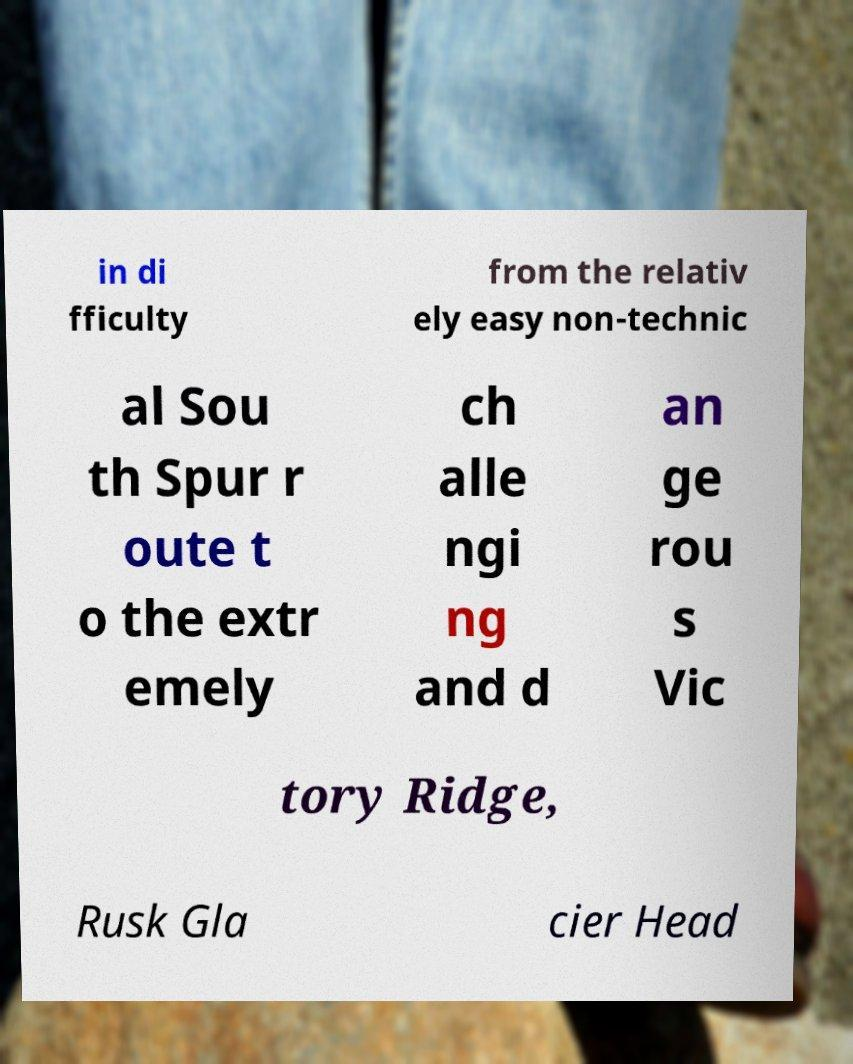Could you extract and type out the text from this image? in di fficulty from the relativ ely easy non-technic al Sou th Spur r oute t o the extr emely ch alle ngi ng and d an ge rou s Vic tory Ridge, Rusk Gla cier Head 